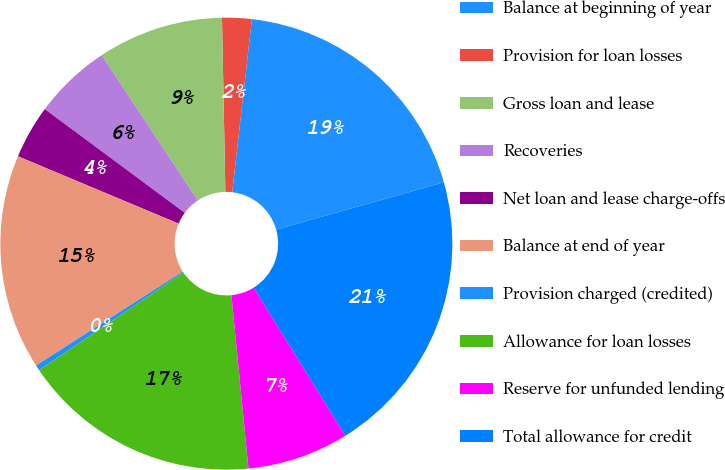Convert chart. <chart><loc_0><loc_0><loc_500><loc_500><pie_chart><fcel>Balance at beginning of year<fcel>Provision for loan losses<fcel>Gross loan and lease<fcel>Recoveries<fcel>Net loan and lease charge-offs<fcel>Balance at end of year<fcel>Provision charged (credited)<fcel>Allowance for loan losses<fcel>Reserve for unfunded lending<fcel>Total allowance for credit<nl><fcel>18.82%<fcel>2.11%<fcel>8.99%<fcel>5.55%<fcel>3.83%<fcel>15.38%<fcel>0.39%<fcel>17.1%<fcel>7.27%<fcel>20.54%<nl></chart> 